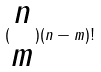<formula> <loc_0><loc_0><loc_500><loc_500>( \begin{matrix} n \\ m \end{matrix} ) ( n - m ) !</formula> 